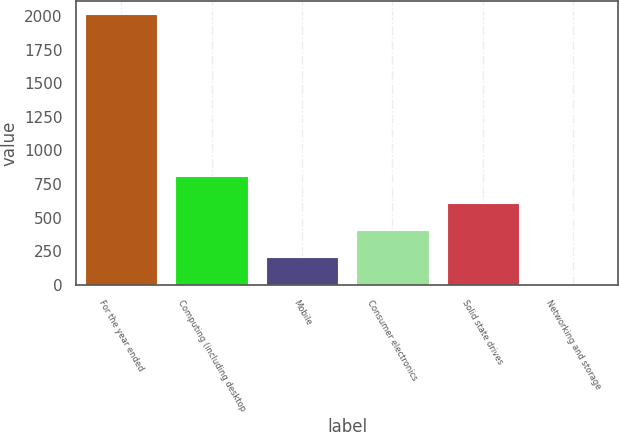Convert chart. <chart><loc_0><loc_0><loc_500><loc_500><bar_chart><fcel>For the year ended<fcel>Computing (including desktop<fcel>Mobile<fcel>Consumer electronics<fcel>Solid state drives<fcel>Networking and storage<nl><fcel>2013<fcel>811.2<fcel>210.3<fcel>410.6<fcel>610.9<fcel>10<nl></chart> 